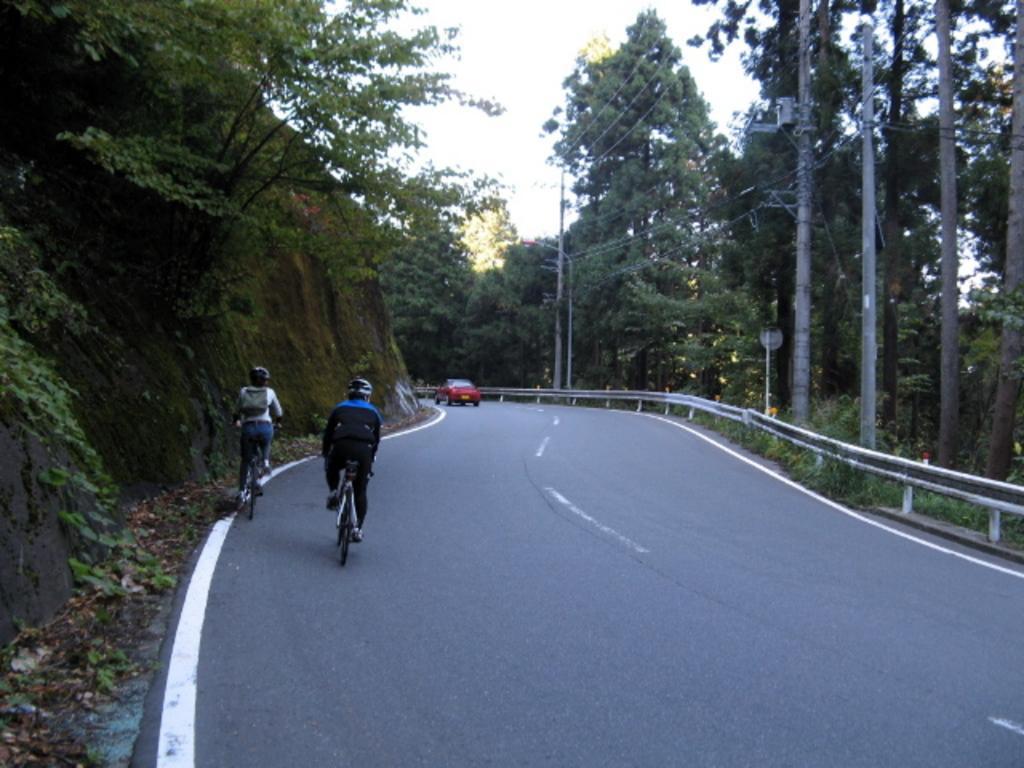Can you describe this image briefly? In this image, we can see two people are riding a bicycle on the road and wearing a helmet. Background we can see a car, trees, poles, plants, wires and sky. 